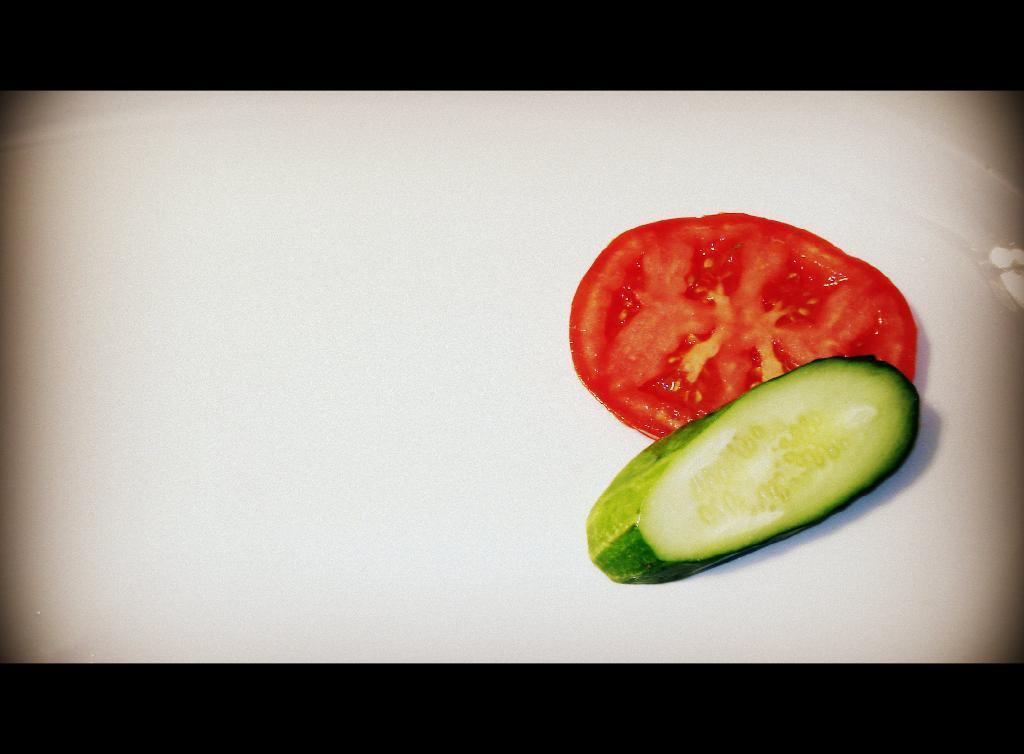Describe this image in one or two sentences. In the center of the image there are vegetable slices. 